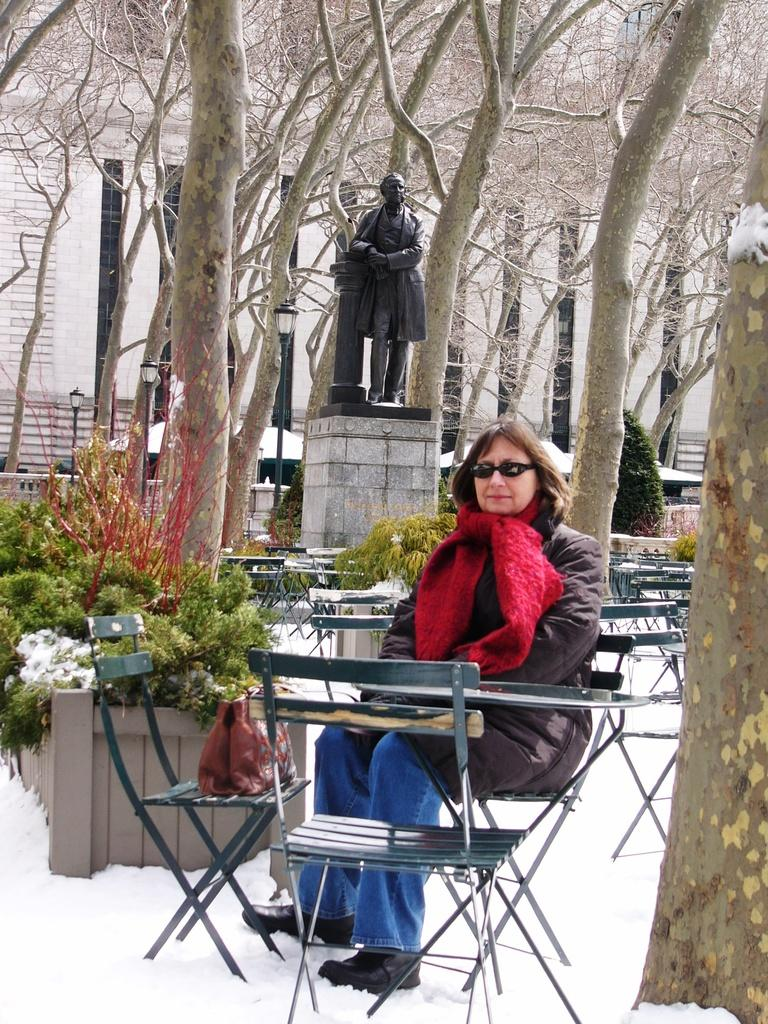What is the person in the image doing? The person is sitting on a chair in the image. Can you describe the person's appearance? The person is wearing glasses. How many chairs are visible in the image? There are chairs in the image. What other furniture is present in the image? There is a table in the image. What is on the chair next to the person? There is a bag on the chair. What can be seen in the background of the image? There is a building, trees, plants, and a statue in the background of the image. What is the overall setting of the image? The scene is covered in snow. What amusement park ride is visible in the image? There is no amusement park ride present in the image. What is the process of creating the snow in the image? The image is a photograph, and the snow is a natural occurrence, not a process created for the image. 